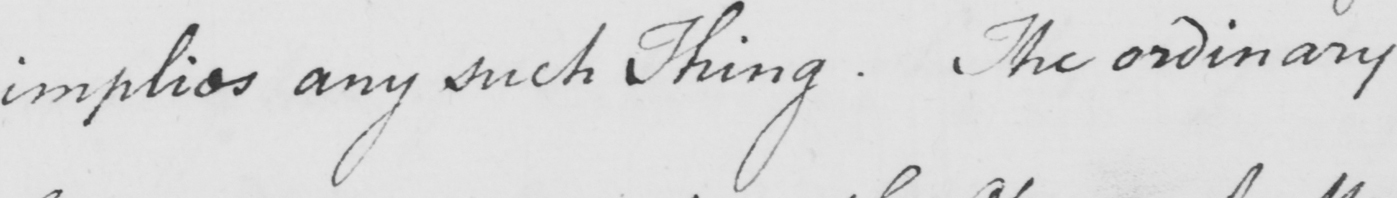Please provide the text content of this handwritten line. implies any such Thing . The ordinary 